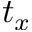<formula> <loc_0><loc_0><loc_500><loc_500>t _ { x }</formula> 